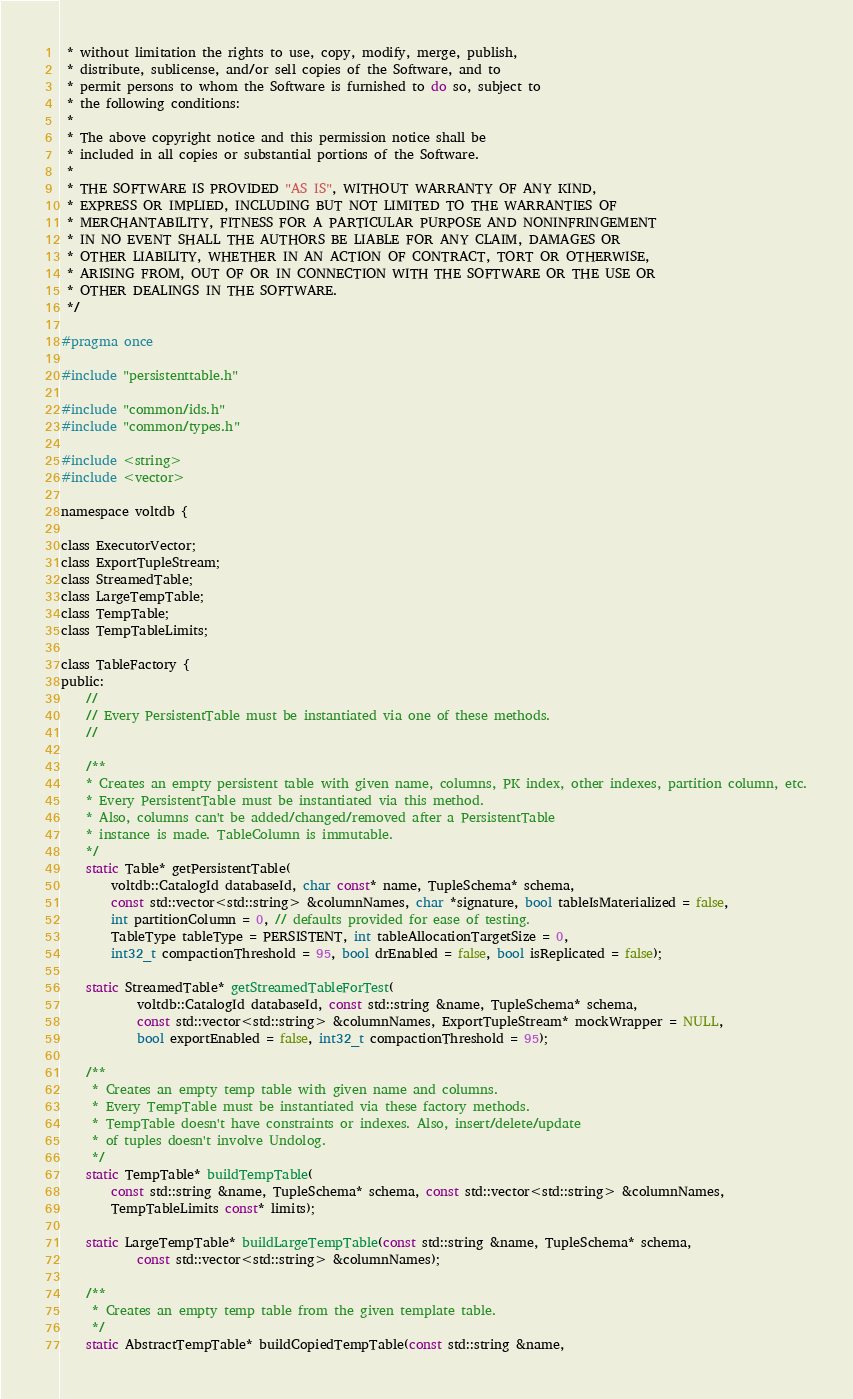Convert code to text. <code><loc_0><loc_0><loc_500><loc_500><_C_> * without limitation the rights to use, copy, modify, merge, publish,
 * distribute, sublicense, and/or sell copies of the Software, and to
 * permit persons to whom the Software is furnished to do so, subject to
 * the following conditions:
 *
 * The above copyright notice and this permission notice shall be
 * included in all copies or substantial portions of the Software.
 *
 * THE SOFTWARE IS PROVIDED "AS IS", WITHOUT WARRANTY OF ANY KIND,
 * EXPRESS OR IMPLIED, INCLUDING BUT NOT LIMITED TO THE WARRANTIES OF
 * MERCHANTABILITY, FITNESS FOR A PARTICULAR PURPOSE AND NONINFRINGEMENT
 * IN NO EVENT SHALL THE AUTHORS BE LIABLE FOR ANY CLAIM, DAMAGES OR
 * OTHER LIABILITY, WHETHER IN AN ACTION OF CONTRACT, TORT OR OTHERWISE,
 * ARISING FROM, OUT OF OR IN CONNECTION WITH THE SOFTWARE OR THE USE OR
 * OTHER DEALINGS IN THE SOFTWARE.
 */

#pragma once

#include "persistenttable.h"

#include "common/ids.h"
#include "common/types.h"

#include <string>
#include <vector>

namespace voltdb {

class ExecutorVector;
class ExportTupleStream;
class StreamedTable;
class LargeTempTable;
class TempTable;
class TempTableLimits;

class TableFactory {
public:
    //
    // Every PersistentTable must be instantiated via one of these methods.
    //

    /**
    * Creates an empty persistent table with given name, columns, PK index, other indexes, partition column, etc.
    * Every PersistentTable must be instantiated via this method.
    * Also, columns can't be added/changed/removed after a PersistentTable
    * instance is made. TableColumn is immutable.
    */
    static Table* getPersistentTable(
        voltdb::CatalogId databaseId, char const* name, TupleSchema* schema,
        const std::vector<std::string> &columnNames, char *signature, bool tableIsMaterialized = false,
        int partitionColumn = 0, // defaults provided for ease of testing.
        TableType tableType = PERSISTENT, int tableAllocationTargetSize = 0,
        int32_t compactionThreshold = 95, bool drEnabled = false, bool isReplicated = false);

    static StreamedTable* getStreamedTableForTest(
            voltdb::CatalogId databaseId, const std::string &name, TupleSchema* schema,
            const std::vector<std::string> &columnNames, ExportTupleStream* mockWrapper = NULL,
            bool exportEnabled = false, int32_t compactionThreshold = 95);

    /**
     * Creates an empty temp table with given name and columns.
     * Every TempTable must be instantiated via these factory methods.
     * TempTable doesn't have constraints or indexes. Also, insert/delete/update
     * of tuples doesn't involve Undolog.
     */
    static TempTable* buildTempTable(
        const std::string &name, TupleSchema* schema, const std::vector<std::string> &columnNames,
        TempTableLimits const* limits);

    static LargeTempTable* buildLargeTempTable(const std::string &name, TupleSchema* schema,
            const std::vector<std::string> &columnNames);

    /**
     * Creates an empty temp table from the given template table.
     */
    static AbstractTempTable* buildCopiedTempTable(const std::string &name,</code> 